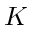Convert formula to latex. <formula><loc_0><loc_0><loc_500><loc_500>K</formula> 